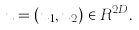Convert formula to latex. <formula><loc_0><loc_0><loc_500><loc_500>u = ( u _ { 1 } , u _ { 2 } ) \in R ^ { 2 D } .</formula> 